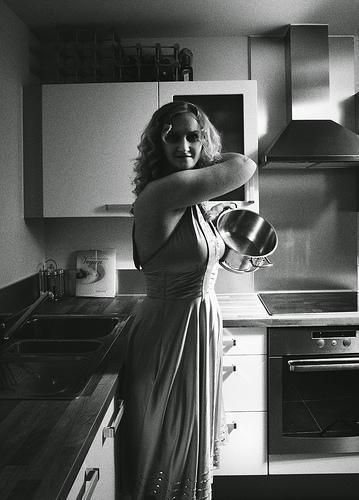How many people are in the picture?
Give a very brief answer. 1. 